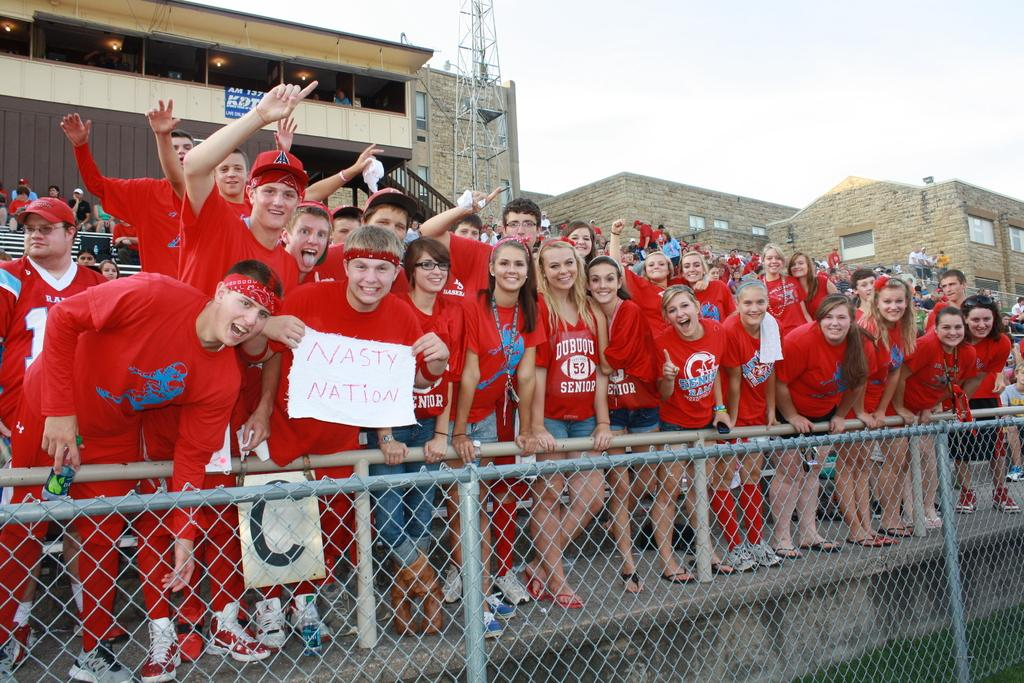What can be seen in the foreground of the image? There are people standing in front of the image. What are the people holding in the image? The people are holding a metal fence. What type of structures can be seen in the background of the image? There are buildings and a tower in the background of the image. What is visible in the sky in the image? The sky is visible in the background of the image. Can you tell me how many flocks of birds are flying over the tower in the image? There are no birds or flocks visible in the image; it only features people holding a metal fence, buildings, a tower, and the sky. What channel is the tower broadcasting in the image? The image does not provide any information about the tower's broadcasting capabilities or channels. 